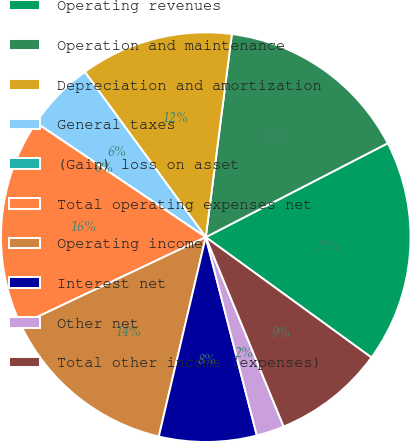<chart> <loc_0><loc_0><loc_500><loc_500><pie_chart><fcel>Operating revenues<fcel>Operation and maintenance<fcel>Depreciation and amortization<fcel>General taxes<fcel>(Gain) loss on asset<fcel>Total operating expenses net<fcel>Operating income<fcel>Interest net<fcel>Other net<fcel>Total other income (expenses)<nl><fcel>17.58%<fcel>15.38%<fcel>12.09%<fcel>5.5%<fcel>0.0%<fcel>16.48%<fcel>14.28%<fcel>7.69%<fcel>2.2%<fcel>8.79%<nl></chart> 